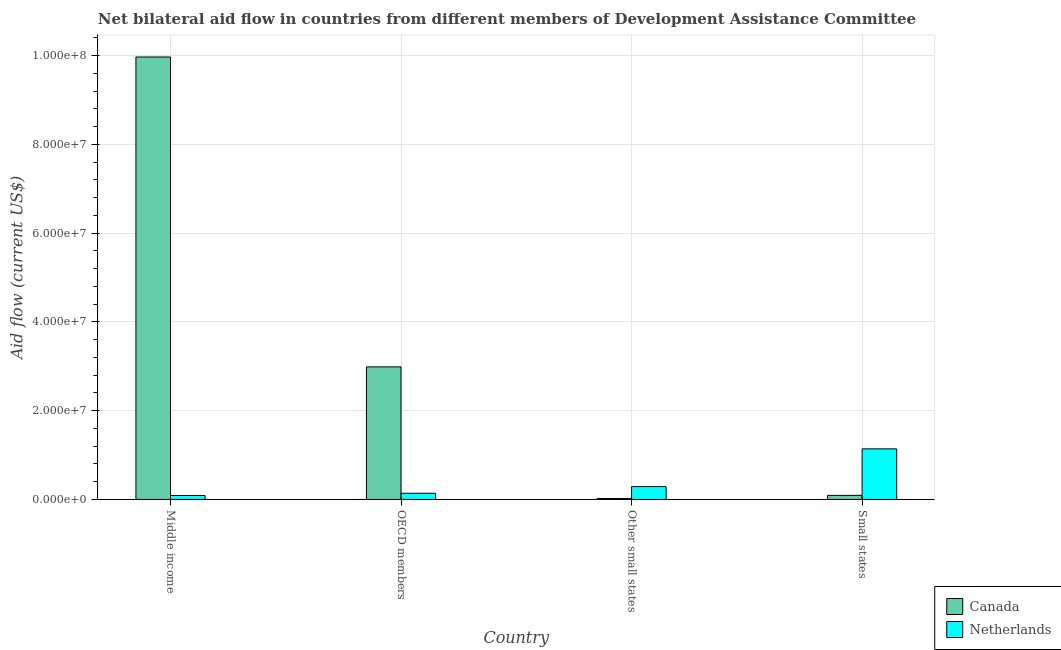Are the number of bars per tick equal to the number of legend labels?
Offer a very short reply. Yes. Are the number of bars on each tick of the X-axis equal?
Ensure brevity in your answer.  Yes. How many bars are there on the 2nd tick from the right?
Make the answer very short. 2. What is the label of the 2nd group of bars from the left?
Provide a short and direct response. OECD members. In how many cases, is the number of bars for a given country not equal to the number of legend labels?
Give a very brief answer. 0. What is the amount of aid given by canada in OECD members?
Keep it short and to the point. 2.99e+07. Across all countries, what is the maximum amount of aid given by netherlands?
Your answer should be compact. 1.14e+07. Across all countries, what is the minimum amount of aid given by canada?
Your answer should be very brief. 2.20e+05. In which country was the amount of aid given by netherlands maximum?
Offer a very short reply. Small states. In which country was the amount of aid given by canada minimum?
Your answer should be compact. Other small states. What is the total amount of aid given by netherlands in the graph?
Your response must be concise. 1.66e+07. What is the difference between the amount of aid given by netherlands in Other small states and that in Small states?
Provide a short and direct response. -8.50e+06. What is the difference between the amount of aid given by canada in Small states and the amount of aid given by netherlands in Middle income?
Your response must be concise. 2.00e+04. What is the average amount of aid given by netherlands per country?
Your answer should be very brief. 4.15e+06. What is the difference between the amount of aid given by netherlands and amount of aid given by canada in OECD members?
Your answer should be very brief. -2.85e+07. In how many countries, is the amount of aid given by netherlands greater than 80000000 US$?
Provide a short and direct response. 0. What is the ratio of the amount of aid given by canada in OECD members to that in Other small states?
Keep it short and to the point. 135.82. What is the difference between the highest and the second highest amount of aid given by canada?
Offer a very short reply. 6.98e+07. What is the difference between the highest and the lowest amount of aid given by netherlands?
Offer a terse response. 1.05e+07. Is the sum of the amount of aid given by canada in OECD members and Other small states greater than the maximum amount of aid given by netherlands across all countries?
Ensure brevity in your answer.  Yes. How many countries are there in the graph?
Your answer should be compact. 4. Where does the legend appear in the graph?
Offer a very short reply. Bottom right. What is the title of the graph?
Ensure brevity in your answer.  Net bilateral aid flow in countries from different members of Development Assistance Committee. What is the label or title of the Y-axis?
Offer a very short reply. Aid flow (current US$). What is the Aid flow (current US$) of Canada in Middle income?
Ensure brevity in your answer.  9.97e+07. What is the Aid flow (current US$) of Netherlands in Middle income?
Provide a short and direct response. 9.00e+05. What is the Aid flow (current US$) of Canada in OECD members?
Keep it short and to the point. 2.99e+07. What is the Aid flow (current US$) of Netherlands in OECD members?
Your response must be concise. 1.40e+06. What is the Aid flow (current US$) of Canada in Other small states?
Ensure brevity in your answer.  2.20e+05. What is the Aid flow (current US$) in Netherlands in Other small states?
Your answer should be very brief. 2.90e+06. What is the Aid flow (current US$) in Canada in Small states?
Your response must be concise. 9.20e+05. What is the Aid flow (current US$) in Netherlands in Small states?
Offer a very short reply. 1.14e+07. Across all countries, what is the maximum Aid flow (current US$) of Canada?
Offer a terse response. 9.97e+07. Across all countries, what is the maximum Aid flow (current US$) in Netherlands?
Keep it short and to the point. 1.14e+07. Across all countries, what is the minimum Aid flow (current US$) of Canada?
Offer a very short reply. 2.20e+05. Across all countries, what is the minimum Aid flow (current US$) of Netherlands?
Make the answer very short. 9.00e+05. What is the total Aid flow (current US$) in Canada in the graph?
Provide a succinct answer. 1.31e+08. What is the total Aid flow (current US$) in Netherlands in the graph?
Offer a terse response. 1.66e+07. What is the difference between the Aid flow (current US$) in Canada in Middle income and that in OECD members?
Provide a short and direct response. 6.98e+07. What is the difference between the Aid flow (current US$) in Netherlands in Middle income and that in OECD members?
Keep it short and to the point. -5.00e+05. What is the difference between the Aid flow (current US$) of Canada in Middle income and that in Other small states?
Your answer should be compact. 9.95e+07. What is the difference between the Aid flow (current US$) of Canada in Middle income and that in Small states?
Give a very brief answer. 9.88e+07. What is the difference between the Aid flow (current US$) of Netherlands in Middle income and that in Small states?
Keep it short and to the point. -1.05e+07. What is the difference between the Aid flow (current US$) in Canada in OECD members and that in Other small states?
Keep it short and to the point. 2.97e+07. What is the difference between the Aid flow (current US$) of Netherlands in OECD members and that in Other small states?
Give a very brief answer. -1.50e+06. What is the difference between the Aid flow (current US$) in Canada in OECD members and that in Small states?
Keep it short and to the point. 2.90e+07. What is the difference between the Aid flow (current US$) of Netherlands in OECD members and that in Small states?
Your answer should be compact. -1.00e+07. What is the difference between the Aid flow (current US$) of Canada in Other small states and that in Small states?
Ensure brevity in your answer.  -7.00e+05. What is the difference between the Aid flow (current US$) of Netherlands in Other small states and that in Small states?
Offer a terse response. -8.50e+06. What is the difference between the Aid flow (current US$) of Canada in Middle income and the Aid flow (current US$) of Netherlands in OECD members?
Keep it short and to the point. 9.83e+07. What is the difference between the Aid flow (current US$) in Canada in Middle income and the Aid flow (current US$) in Netherlands in Other small states?
Your response must be concise. 9.68e+07. What is the difference between the Aid flow (current US$) of Canada in Middle income and the Aid flow (current US$) of Netherlands in Small states?
Offer a very short reply. 8.83e+07. What is the difference between the Aid flow (current US$) in Canada in OECD members and the Aid flow (current US$) in Netherlands in Other small states?
Ensure brevity in your answer.  2.70e+07. What is the difference between the Aid flow (current US$) in Canada in OECD members and the Aid flow (current US$) in Netherlands in Small states?
Ensure brevity in your answer.  1.85e+07. What is the difference between the Aid flow (current US$) in Canada in Other small states and the Aid flow (current US$) in Netherlands in Small states?
Offer a very short reply. -1.12e+07. What is the average Aid flow (current US$) of Canada per country?
Offer a terse response. 3.27e+07. What is the average Aid flow (current US$) of Netherlands per country?
Keep it short and to the point. 4.15e+06. What is the difference between the Aid flow (current US$) of Canada and Aid flow (current US$) of Netherlands in Middle income?
Provide a short and direct response. 9.88e+07. What is the difference between the Aid flow (current US$) in Canada and Aid flow (current US$) in Netherlands in OECD members?
Your response must be concise. 2.85e+07. What is the difference between the Aid flow (current US$) in Canada and Aid flow (current US$) in Netherlands in Other small states?
Your response must be concise. -2.68e+06. What is the difference between the Aid flow (current US$) in Canada and Aid flow (current US$) in Netherlands in Small states?
Provide a short and direct response. -1.05e+07. What is the ratio of the Aid flow (current US$) of Canada in Middle income to that in OECD members?
Ensure brevity in your answer.  3.34. What is the ratio of the Aid flow (current US$) in Netherlands in Middle income to that in OECD members?
Give a very brief answer. 0.64. What is the ratio of the Aid flow (current US$) of Canada in Middle income to that in Other small states?
Keep it short and to the point. 453.18. What is the ratio of the Aid flow (current US$) in Netherlands in Middle income to that in Other small states?
Ensure brevity in your answer.  0.31. What is the ratio of the Aid flow (current US$) in Canada in Middle income to that in Small states?
Provide a succinct answer. 108.37. What is the ratio of the Aid flow (current US$) in Netherlands in Middle income to that in Small states?
Your response must be concise. 0.08. What is the ratio of the Aid flow (current US$) of Canada in OECD members to that in Other small states?
Your response must be concise. 135.82. What is the ratio of the Aid flow (current US$) in Netherlands in OECD members to that in Other small states?
Your answer should be compact. 0.48. What is the ratio of the Aid flow (current US$) of Canada in OECD members to that in Small states?
Your answer should be very brief. 32.48. What is the ratio of the Aid flow (current US$) of Netherlands in OECD members to that in Small states?
Your answer should be compact. 0.12. What is the ratio of the Aid flow (current US$) of Canada in Other small states to that in Small states?
Offer a terse response. 0.24. What is the ratio of the Aid flow (current US$) of Netherlands in Other small states to that in Small states?
Provide a succinct answer. 0.25. What is the difference between the highest and the second highest Aid flow (current US$) in Canada?
Your answer should be compact. 6.98e+07. What is the difference between the highest and the second highest Aid flow (current US$) of Netherlands?
Make the answer very short. 8.50e+06. What is the difference between the highest and the lowest Aid flow (current US$) of Canada?
Ensure brevity in your answer.  9.95e+07. What is the difference between the highest and the lowest Aid flow (current US$) of Netherlands?
Your answer should be compact. 1.05e+07. 